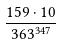<formula> <loc_0><loc_0><loc_500><loc_500>\frac { 1 5 9 \cdot 1 0 } { 3 6 3 ^ { 3 4 7 } }</formula> 